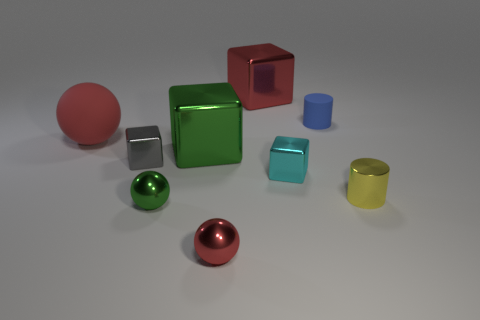There is a cyan object that is right of the large shiny thing that is in front of the big matte thing; is there a big green object in front of it?
Offer a terse response. No. There is another ball that is the same color as the big ball; what is its size?
Ensure brevity in your answer.  Small. There is a yellow metallic cylinder; are there any tiny red spheres left of it?
Offer a terse response. Yes. What number of other objects are there of the same shape as the small red object?
Give a very brief answer. 2. There is a matte cylinder that is the same size as the yellow shiny thing; what is its color?
Offer a terse response. Blue. Is the number of shiny things that are behind the green shiny cube less than the number of large red cubes to the left of the small green metallic thing?
Provide a succinct answer. No. What number of blue cylinders are on the right side of the metal block that is behind the big red ball that is left of the small yellow object?
Your answer should be compact. 1. The red thing that is the same shape as the cyan shiny object is what size?
Offer a terse response. Large. Are there fewer small blocks to the right of the tiny yellow cylinder than tiny red cylinders?
Offer a terse response. No. Is the cyan shiny thing the same shape as the gray thing?
Offer a terse response. Yes. 